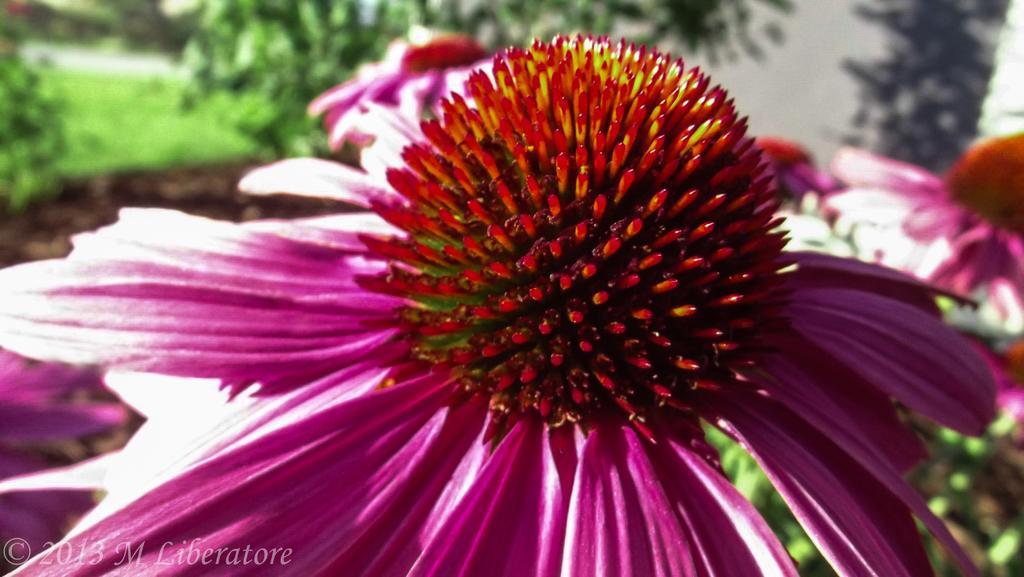Please provide a concise description of this image. In this image we can see flowers. In the background there are trees and grass. 